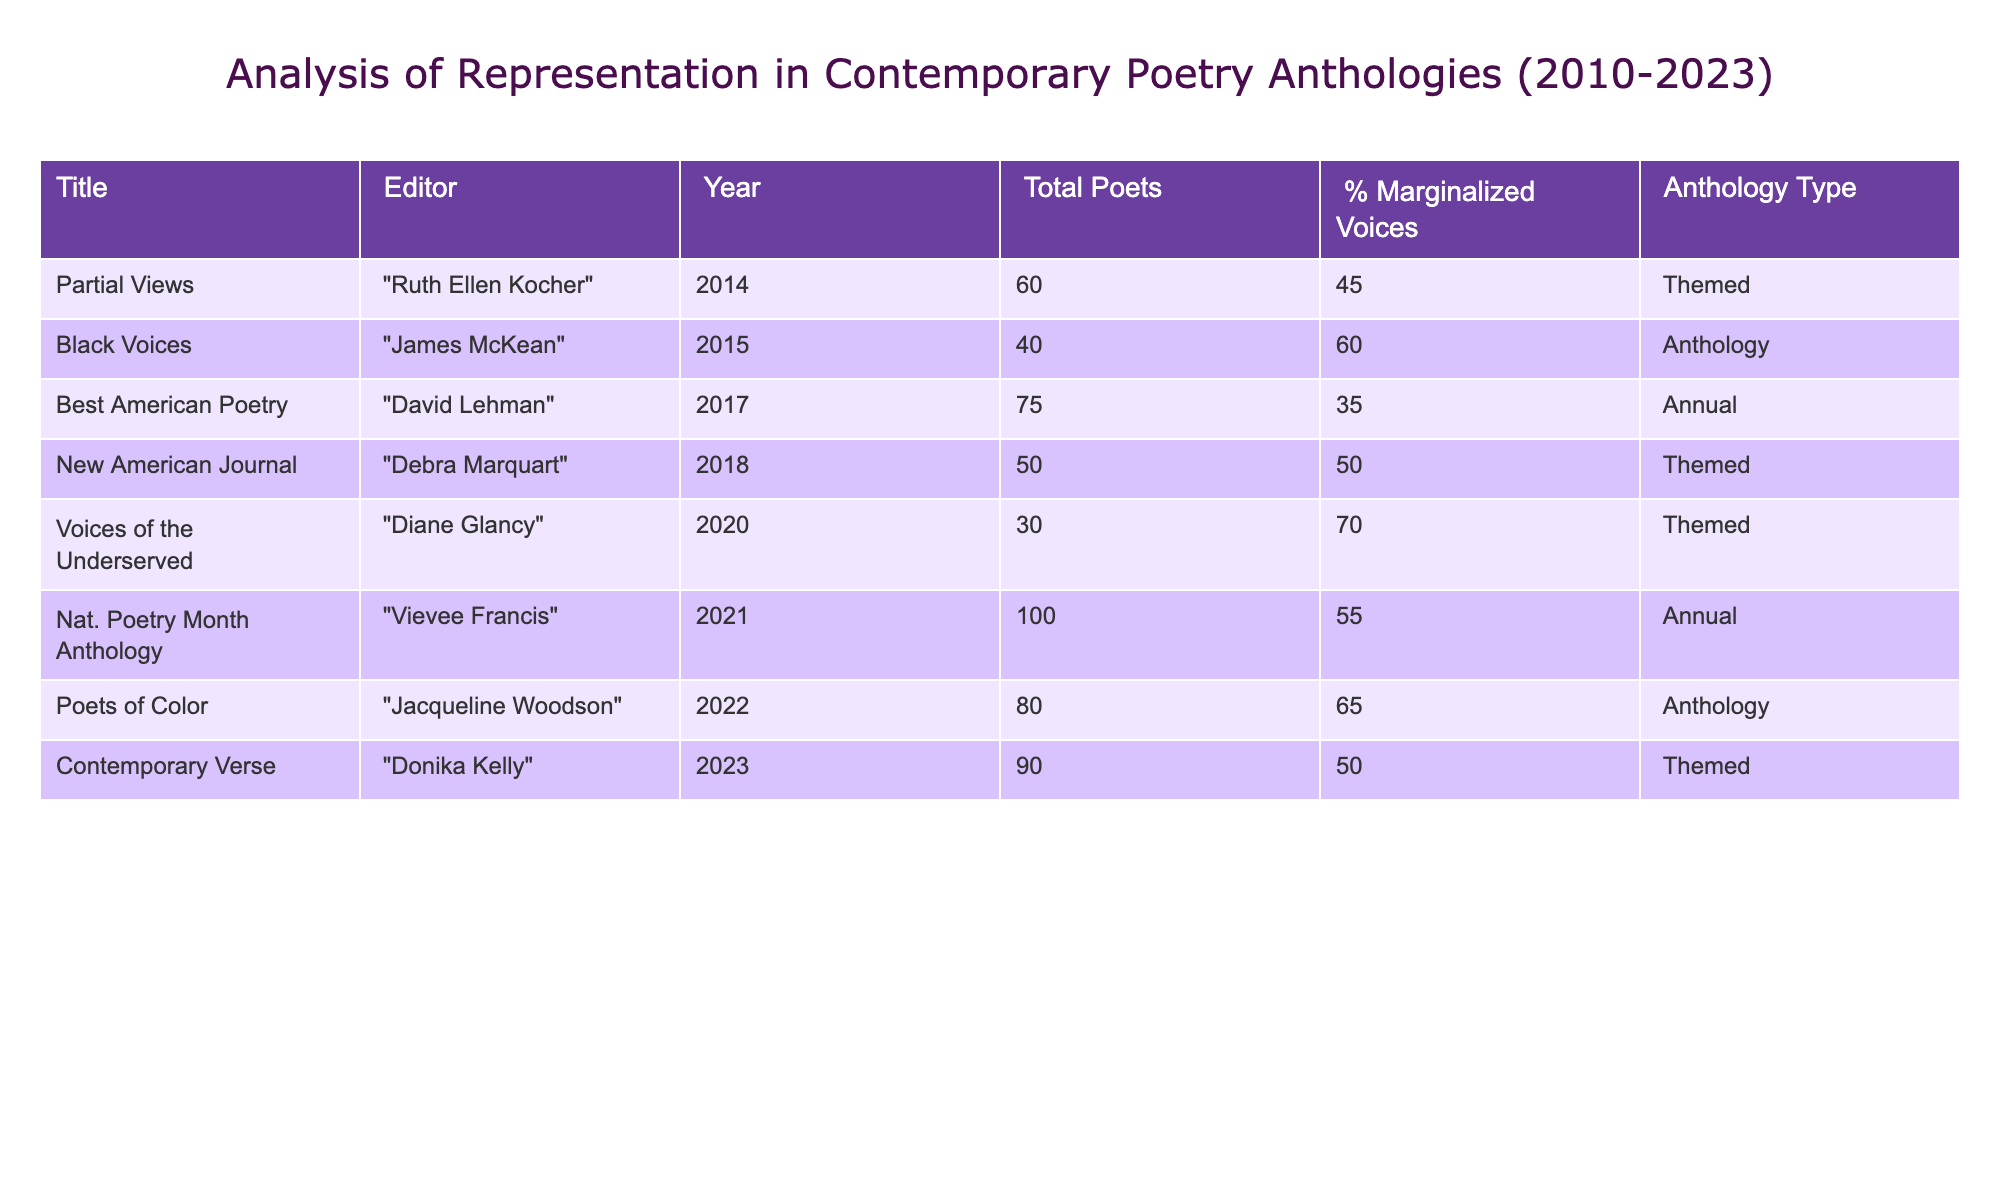What is the total number of poets represented in "Voices of the Underserved"? From the table, I can see that the number of total poets for "Voices of the Underserved" is specifically listed under the "Total Poets" column, which shows 30.
Answer: 30 Which anthology has the highest percentage of marginalized voices? By examining the "% Marginalized Voices" column, the anthology "Voices of the Underserved" has the highest percentage of marginalized voices, which is 70.
Answer: 70 What is the average percentage of marginalized voices for all anthologies? To find the average, I sum the percentages from the "% Marginalized Voices" column (45 + 60 + 35 + 50 + 70 + 55 + 65 + 50 = 430) and then divide by the total number of anthologies (8) giving average of 430/8 = 53.75.
Answer: 53.75 Is "Best American Poetry" an anthology type? The "Best American Poetry" entry under "Anthology Type" is marked as "Annual" indicating it is indeed categorized as an anthology.
Answer: Yes Which anthology published in 2022 has a higher percentage of marginalized voices than the average percentage? The average percentage of marginalized voices is 53.75, and the anthology "Poets of Color" from 2022 has 65%, which is higher than the average. This means this anthology fits the criterion.
Answer: "Poets of Color" How many anthologies were edited by a female editor? By checking the "Editor" column against the list, I find that "Ruth Ellen Kocher," "Debra Marquart," "Diane Glancy," and "Vievee Francis," are all female editors, totaling 4.
Answer: 4 What is the difference in total poets between the anthology with the highest and lowest total poets? The anthology "Nat. Poetry Month Anthology" has the highest with 100 poets and "Voices of the Underserved" has the lowest with 30. The difference is 100 - 30 = 70.
Answer: 70 Are there any themed anthologies that feature more than 50% marginalized voices? Looking at the themed anthologies in the table, "Partial Views" with 45%, "New American Journal" with 50%, and "Voices of the Underserved" with 70% are noted, thus confirming that 'Voices of the Underserved' is the only themed anthology above 50%.
Answer: Yes 